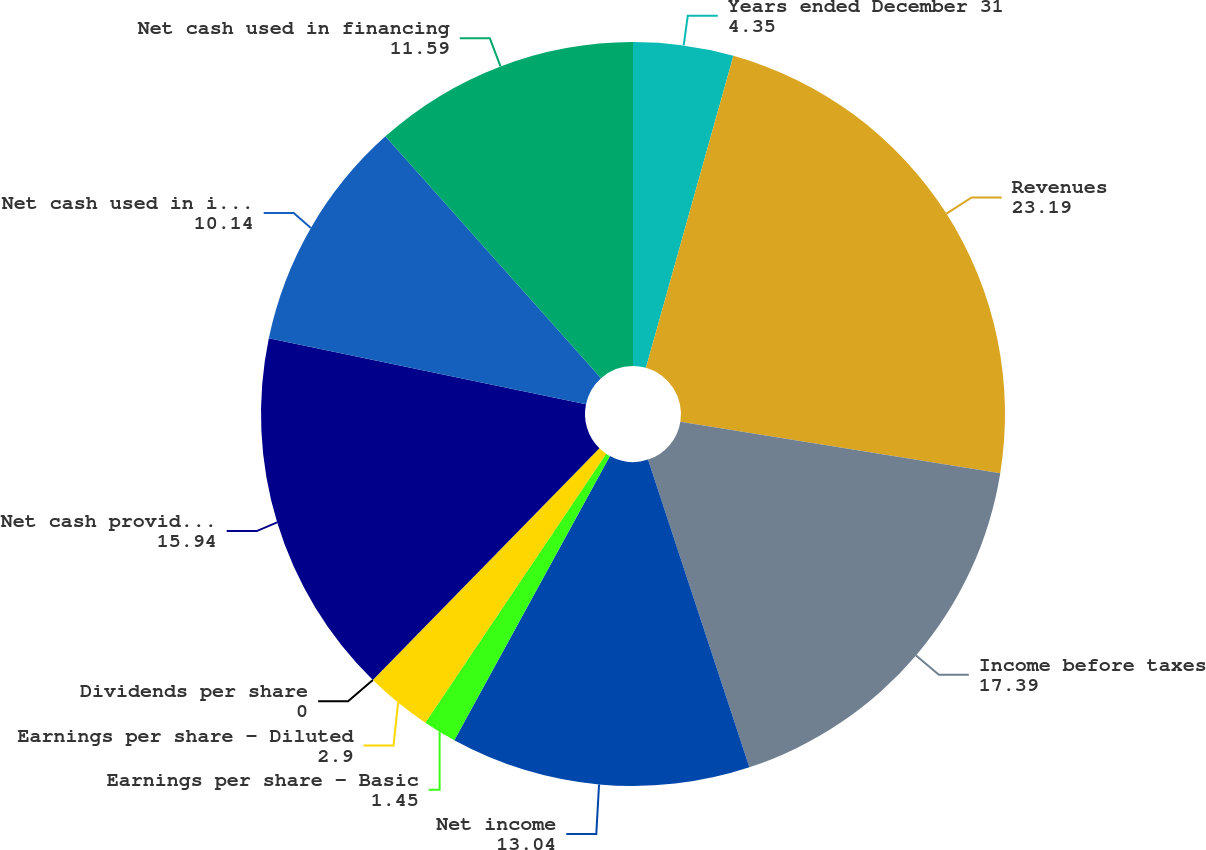Convert chart to OTSL. <chart><loc_0><loc_0><loc_500><loc_500><pie_chart><fcel>Years ended December 31<fcel>Revenues<fcel>Income before taxes<fcel>Net income<fcel>Earnings per share - Basic<fcel>Earnings per share - Diluted<fcel>Dividends per share<fcel>Net cash provided by operating<fcel>Net cash used in investing<fcel>Net cash used in financing<nl><fcel>4.35%<fcel>23.19%<fcel>17.39%<fcel>13.04%<fcel>1.45%<fcel>2.9%<fcel>0.0%<fcel>15.94%<fcel>10.14%<fcel>11.59%<nl></chart> 